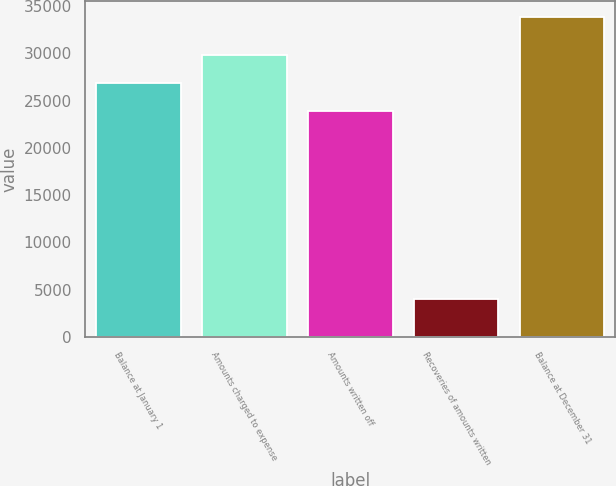Convert chart. <chart><loc_0><loc_0><loc_500><loc_500><bar_chart><fcel>Balance at January 1<fcel>Amounts charged to expense<fcel>Amounts written off<fcel>Recoveries of amounts written<fcel>Balance at December 31<nl><fcel>26892.3<fcel>29870.6<fcel>23914<fcel>4040<fcel>33823<nl></chart> 